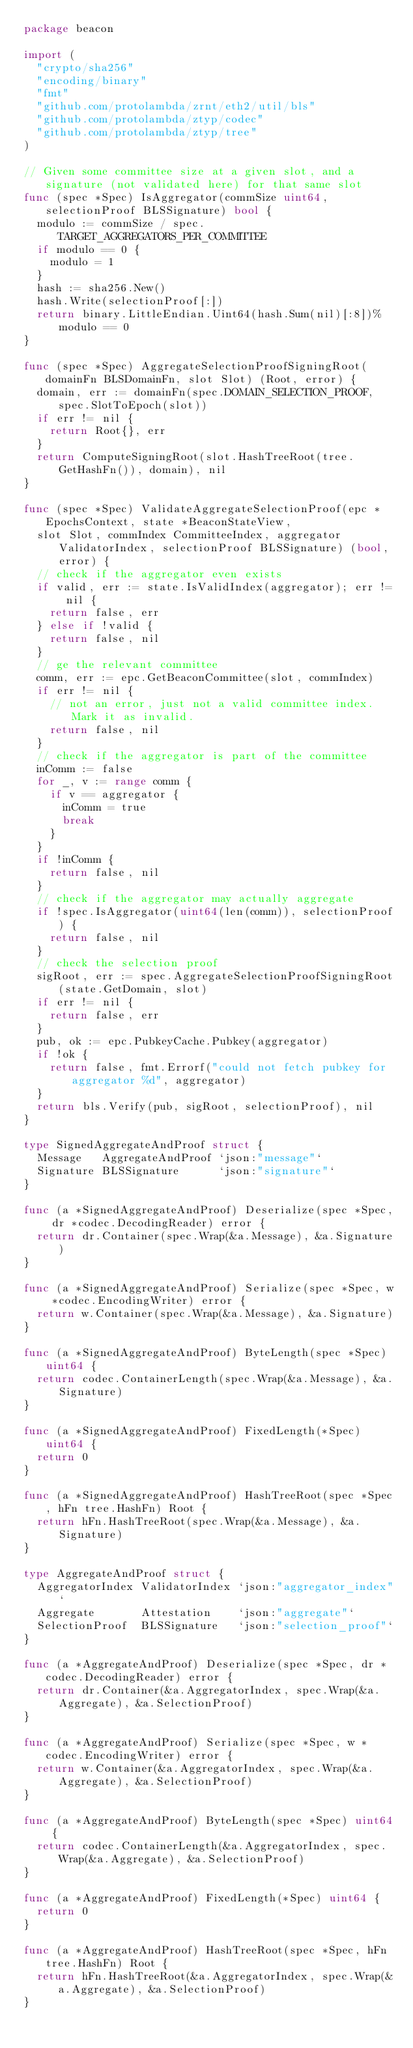<code> <loc_0><loc_0><loc_500><loc_500><_Go_>package beacon

import (
	"crypto/sha256"
	"encoding/binary"
	"fmt"
	"github.com/protolambda/zrnt/eth2/util/bls"
	"github.com/protolambda/ztyp/codec"
	"github.com/protolambda/ztyp/tree"
)

// Given some committee size at a given slot, and a signature (not validated here) for that same slot
func (spec *Spec) IsAggregator(commSize uint64, selectionProof BLSSignature) bool {
	modulo := commSize / spec.TARGET_AGGREGATORS_PER_COMMITTEE
	if modulo == 0 {
		modulo = 1
	}
	hash := sha256.New()
	hash.Write(selectionProof[:])
	return binary.LittleEndian.Uint64(hash.Sum(nil)[:8])%modulo == 0
}

func (spec *Spec) AggregateSelectionProofSigningRoot(domainFn BLSDomainFn, slot Slot) (Root, error) {
	domain, err := domainFn(spec.DOMAIN_SELECTION_PROOF, spec.SlotToEpoch(slot))
	if err != nil {
		return Root{}, err
	}
	return ComputeSigningRoot(slot.HashTreeRoot(tree.GetHashFn()), domain), nil
}

func (spec *Spec) ValidateAggregateSelectionProof(epc *EpochsContext, state *BeaconStateView,
	slot Slot, commIndex CommitteeIndex, aggregator ValidatorIndex, selectionProof BLSSignature) (bool, error) {
	// check if the aggregator even exists
	if valid, err := state.IsValidIndex(aggregator); err != nil {
		return false, err
	} else if !valid {
		return false, nil
	}
	// ge the relevant committee
	comm, err := epc.GetBeaconCommittee(slot, commIndex)
	if err != nil {
		// not an error, just not a valid committee index. Mark it as invalid.
		return false, nil
	}
	// check if the aggregator is part of the committee
	inComm := false
	for _, v := range comm {
		if v == aggregator {
			inComm = true
			break
		}
	}
	if !inComm {
		return false, nil
	}
	// check if the aggregator may actually aggregate
	if !spec.IsAggregator(uint64(len(comm)), selectionProof) {
		return false, nil
	}
	// check the selection proof
	sigRoot, err := spec.AggregateSelectionProofSigningRoot(state.GetDomain, slot)
	if err != nil {
		return false, err
	}
	pub, ok := epc.PubkeyCache.Pubkey(aggregator)
	if !ok {
		return false, fmt.Errorf("could not fetch pubkey for aggregator %d", aggregator)
	}
	return bls.Verify(pub, sigRoot, selectionProof), nil
}

type SignedAggregateAndProof struct {
	Message   AggregateAndProof `json:"message"`
	Signature BLSSignature      `json:"signature"`
}

func (a *SignedAggregateAndProof) Deserialize(spec *Spec, dr *codec.DecodingReader) error {
	return dr.Container(spec.Wrap(&a.Message), &a.Signature)
}

func (a *SignedAggregateAndProof) Serialize(spec *Spec, w *codec.EncodingWriter) error {
	return w.Container(spec.Wrap(&a.Message), &a.Signature)
}

func (a *SignedAggregateAndProof) ByteLength(spec *Spec) uint64 {
	return codec.ContainerLength(spec.Wrap(&a.Message), &a.Signature)
}

func (a *SignedAggregateAndProof) FixedLength(*Spec) uint64 {
	return 0
}

func (a *SignedAggregateAndProof) HashTreeRoot(spec *Spec, hFn tree.HashFn) Root {
	return hFn.HashTreeRoot(spec.Wrap(&a.Message), &a.Signature)
}

type AggregateAndProof struct {
	AggregatorIndex ValidatorIndex `json:"aggregator_index"`
	Aggregate       Attestation    `json:"aggregate"`
	SelectionProof  BLSSignature   `json:"selection_proof"`
}

func (a *AggregateAndProof) Deserialize(spec *Spec, dr *codec.DecodingReader) error {
	return dr.Container(&a.AggregatorIndex, spec.Wrap(&a.Aggregate), &a.SelectionProof)
}

func (a *AggregateAndProof) Serialize(spec *Spec, w *codec.EncodingWriter) error {
	return w.Container(&a.AggregatorIndex, spec.Wrap(&a.Aggregate), &a.SelectionProof)
}

func (a *AggregateAndProof) ByteLength(spec *Spec) uint64 {
	return codec.ContainerLength(&a.AggregatorIndex, spec.Wrap(&a.Aggregate), &a.SelectionProof)
}

func (a *AggregateAndProof) FixedLength(*Spec) uint64 {
	return 0
}

func (a *AggregateAndProof) HashTreeRoot(spec *Spec, hFn tree.HashFn) Root {
	return hFn.HashTreeRoot(&a.AggregatorIndex, spec.Wrap(&a.Aggregate), &a.SelectionProof)
}
</code> 